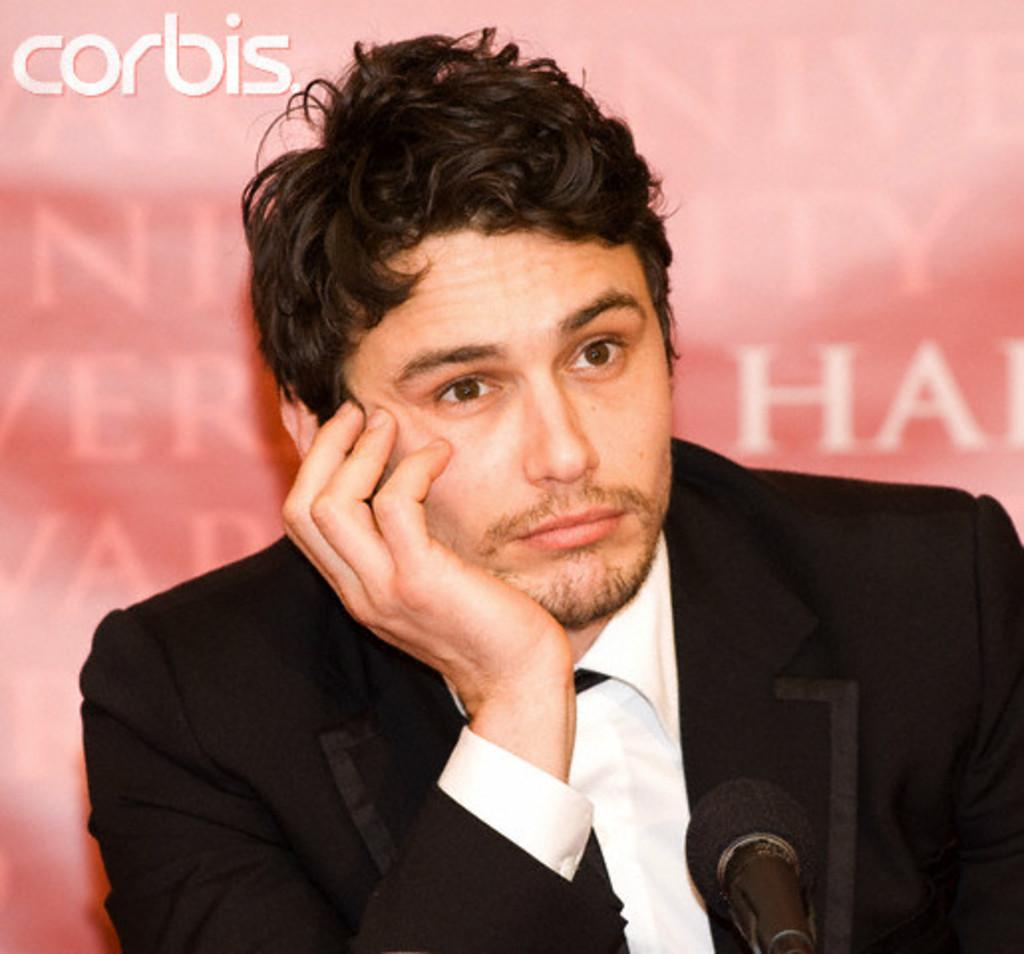Who is the main subject in the image? There is a boy in the center of the image. What object is in front of the boy? There is a microphone in front of the boy. What can be seen in the background of the image? There is a poster in the background of the image. What type of care is being provided to the boy in the image? There is no indication of care being provided in the image; it simply shows a boy with a microphone in front of him and a poster in the background. 